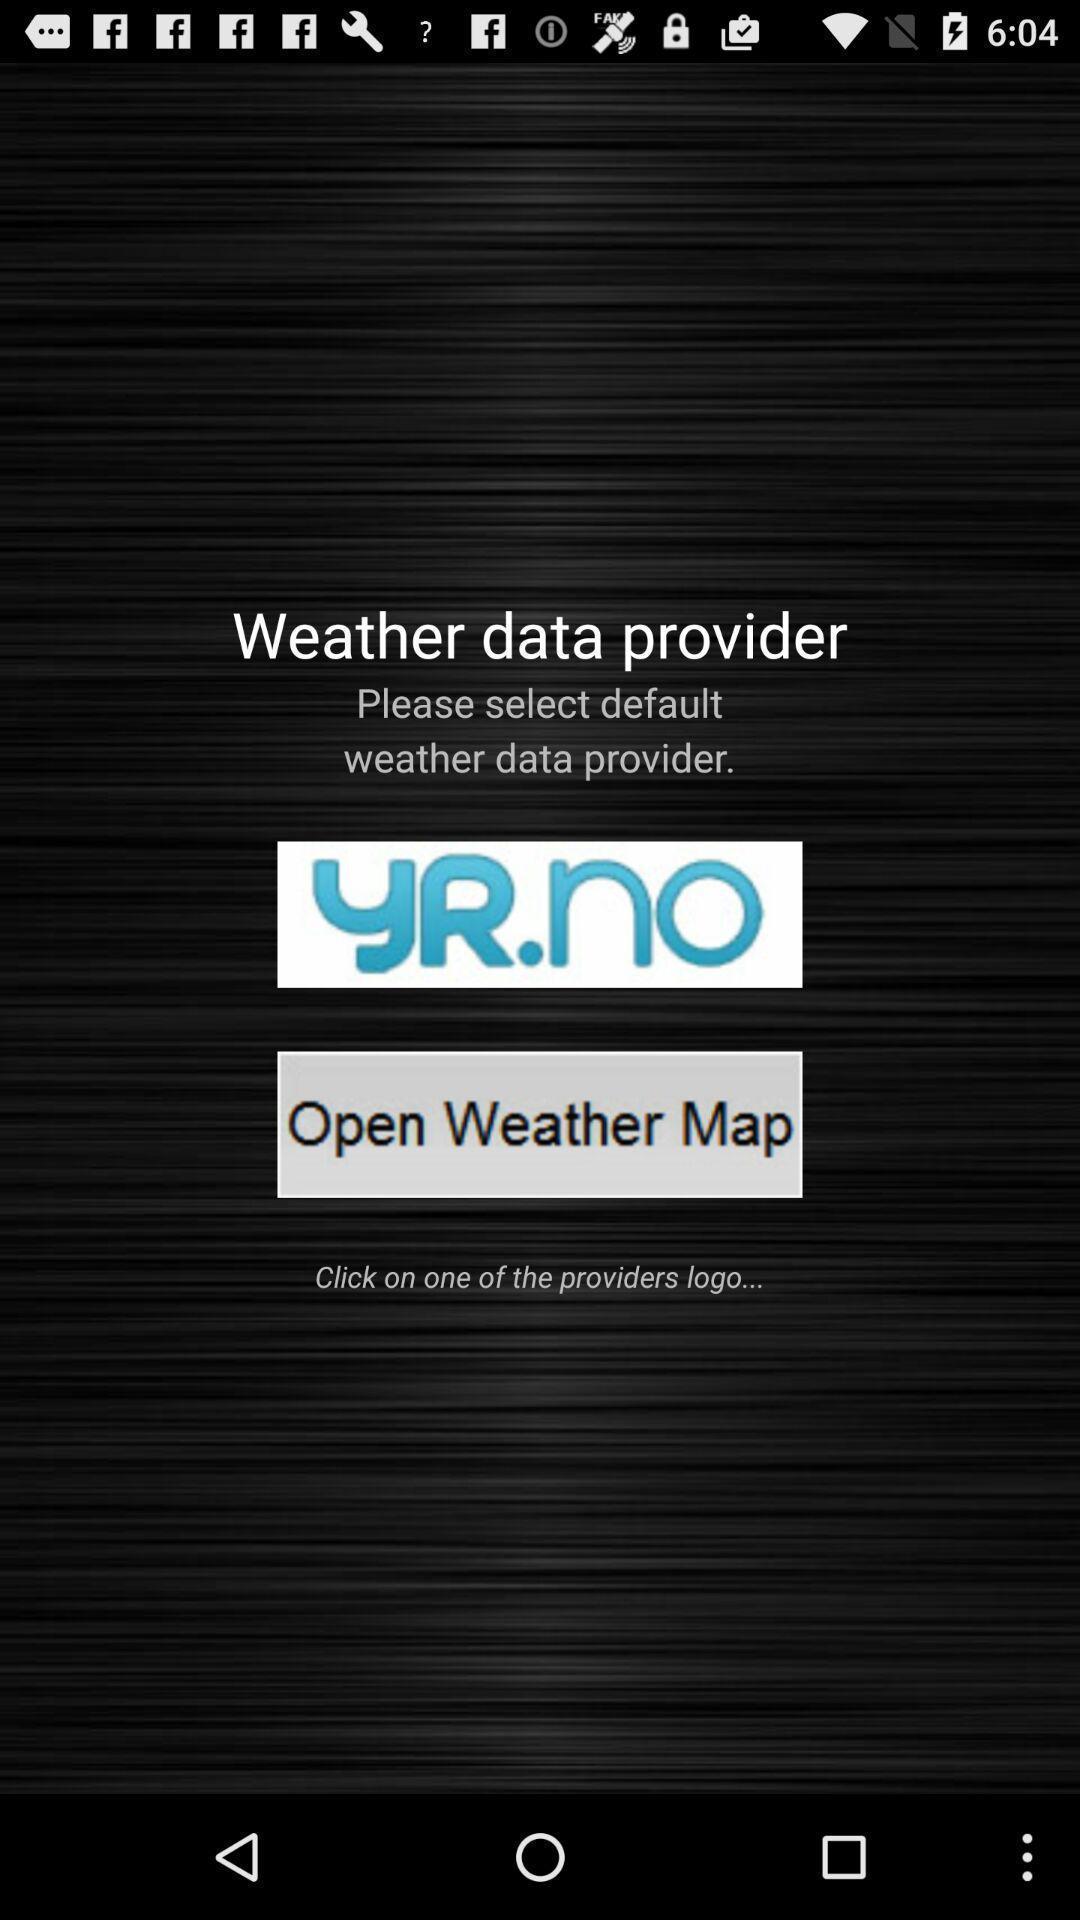Describe the key features of this screenshot. Welcome page of a social app. 